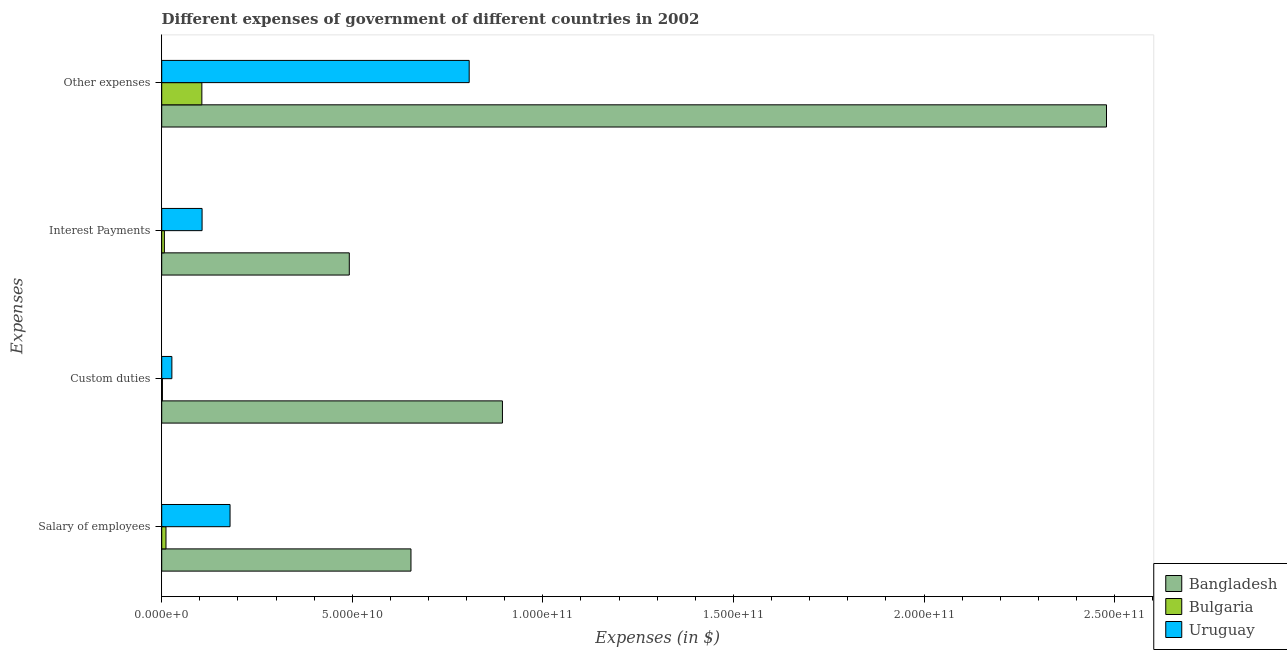How many different coloured bars are there?
Ensure brevity in your answer.  3. How many groups of bars are there?
Make the answer very short. 4. What is the label of the 1st group of bars from the top?
Ensure brevity in your answer.  Other expenses. What is the amount spent on other expenses in Bulgaria?
Your response must be concise. 1.05e+1. Across all countries, what is the maximum amount spent on interest payments?
Your answer should be compact. 4.92e+1. Across all countries, what is the minimum amount spent on interest payments?
Make the answer very short. 7.01e+08. In which country was the amount spent on interest payments minimum?
Your response must be concise. Bulgaria. What is the total amount spent on other expenses in the graph?
Make the answer very short. 3.39e+11. What is the difference between the amount spent on other expenses in Bulgaria and that in Uruguay?
Provide a short and direct response. -7.01e+1. What is the difference between the amount spent on salary of employees in Bangladesh and the amount spent on interest payments in Uruguay?
Provide a short and direct response. 5.48e+1. What is the average amount spent on salary of employees per country?
Make the answer very short. 2.81e+1. What is the difference between the amount spent on salary of employees and amount spent on interest payments in Bulgaria?
Your answer should be compact. 4.22e+08. What is the ratio of the amount spent on interest payments in Bangladesh to that in Bulgaria?
Make the answer very short. 70.2. What is the difference between the highest and the second highest amount spent on salary of employees?
Provide a short and direct response. 4.75e+1. What is the difference between the highest and the lowest amount spent on custom duties?
Your response must be concise. 8.92e+1. In how many countries, is the amount spent on interest payments greater than the average amount spent on interest payments taken over all countries?
Your answer should be compact. 1. Is the sum of the amount spent on custom duties in Bangladesh and Bulgaria greater than the maximum amount spent on interest payments across all countries?
Your answer should be compact. Yes. What does the 1st bar from the top in Interest Payments represents?
Ensure brevity in your answer.  Uruguay. What does the 2nd bar from the bottom in Custom duties represents?
Offer a terse response. Bulgaria. Is it the case that in every country, the sum of the amount spent on salary of employees and amount spent on custom duties is greater than the amount spent on interest payments?
Make the answer very short. Yes. Are all the bars in the graph horizontal?
Make the answer very short. Yes. What is the difference between two consecutive major ticks on the X-axis?
Ensure brevity in your answer.  5.00e+1. Does the graph contain any zero values?
Your answer should be very brief. No. Does the graph contain grids?
Provide a succinct answer. No. What is the title of the graph?
Your answer should be compact. Different expenses of government of different countries in 2002. What is the label or title of the X-axis?
Your answer should be very brief. Expenses (in $). What is the label or title of the Y-axis?
Offer a terse response. Expenses. What is the Expenses (in $) of Bangladesh in Salary of employees?
Your answer should be compact. 6.54e+1. What is the Expenses (in $) in Bulgaria in Salary of employees?
Ensure brevity in your answer.  1.12e+09. What is the Expenses (in $) of Uruguay in Salary of employees?
Give a very brief answer. 1.79e+1. What is the Expenses (in $) in Bangladesh in Custom duties?
Ensure brevity in your answer.  8.94e+1. What is the Expenses (in $) of Bulgaria in Custom duties?
Offer a very short reply. 1.88e+08. What is the Expenses (in $) in Uruguay in Custom duties?
Ensure brevity in your answer.  2.67e+09. What is the Expenses (in $) in Bangladesh in Interest Payments?
Provide a short and direct response. 4.92e+1. What is the Expenses (in $) in Bulgaria in Interest Payments?
Give a very brief answer. 7.01e+08. What is the Expenses (in $) in Uruguay in Interest Payments?
Give a very brief answer. 1.06e+1. What is the Expenses (in $) in Bangladesh in Other expenses?
Offer a very short reply. 2.48e+11. What is the Expenses (in $) of Bulgaria in Other expenses?
Offer a very short reply. 1.05e+1. What is the Expenses (in $) in Uruguay in Other expenses?
Offer a terse response. 8.07e+1. Across all Expenses, what is the maximum Expenses (in $) in Bangladesh?
Provide a succinct answer. 2.48e+11. Across all Expenses, what is the maximum Expenses (in $) of Bulgaria?
Offer a very short reply. 1.05e+1. Across all Expenses, what is the maximum Expenses (in $) in Uruguay?
Ensure brevity in your answer.  8.07e+1. Across all Expenses, what is the minimum Expenses (in $) in Bangladesh?
Make the answer very short. 4.92e+1. Across all Expenses, what is the minimum Expenses (in $) of Bulgaria?
Provide a succinct answer. 1.88e+08. Across all Expenses, what is the minimum Expenses (in $) in Uruguay?
Offer a very short reply. 2.67e+09. What is the total Expenses (in $) of Bangladesh in the graph?
Keep it short and to the point. 4.52e+11. What is the total Expenses (in $) of Bulgaria in the graph?
Your response must be concise. 1.25e+1. What is the total Expenses (in $) in Uruguay in the graph?
Ensure brevity in your answer.  1.12e+11. What is the difference between the Expenses (in $) of Bangladesh in Salary of employees and that in Custom duties?
Make the answer very short. -2.40e+1. What is the difference between the Expenses (in $) in Bulgaria in Salary of employees and that in Custom duties?
Make the answer very short. 9.34e+08. What is the difference between the Expenses (in $) of Uruguay in Salary of employees and that in Custom duties?
Offer a terse response. 1.53e+1. What is the difference between the Expenses (in $) of Bangladesh in Salary of employees and that in Interest Payments?
Offer a very short reply. 1.62e+1. What is the difference between the Expenses (in $) in Bulgaria in Salary of employees and that in Interest Payments?
Make the answer very short. 4.22e+08. What is the difference between the Expenses (in $) in Uruguay in Salary of employees and that in Interest Payments?
Make the answer very short. 7.34e+09. What is the difference between the Expenses (in $) in Bangladesh in Salary of employees and that in Other expenses?
Provide a succinct answer. -1.82e+11. What is the difference between the Expenses (in $) of Bulgaria in Salary of employees and that in Other expenses?
Your answer should be very brief. -9.41e+09. What is the difference between the Expenses (in $) of Uruguay in Salary of employees and that in Other expenses?
Ensure brevity in your answer.  -6.27e+1. What is the difference between the Expenses (in $) of Bangladesh in Custom duties and that in Interest Payments?
Keep it short and to the point. 4.02e+1. What is the difference between the Expenses (in $) in Bulgaria in Custom duties and that in Interest Payments?
Your answer should be compact. -5.13e+08. What is the difference between the Expenses (in $) in Uruguay in Custom duties and that in Interest Payments?
Offer a terse response. -7.92e+09. What is the difference between the Expenses (in $) in Bangladesh in Custom duties and that in Other expenses?
Provide a succinct answer. -1.58e+11. What is the difference between the Expenses (in $) in Bulgaria in Custom duties and that in Other expenses?
Make the answer very short. -1.03e+1. What is the difference between the Expenses (in $) in Uruguay in Custom duties and that in Other expenses?
Your response must be concise. -7.80e+1. What is the difference between the Expenses (in $) of Bangladesh in Interest Payments and that in Other expenses?
Your answer should be compact. -1.99e+11. What is the difference between the Expenses (in $) in Bulgaria in Interest Payments and that in Other expenses?
Offer a terse response. -9.83e+09. What is the difference between the Expenses (in $) in Uruguay in Interest Payments and that in Other expenses?
Your answer should be compact. -7.01e+1. What is the difference between the Expenses (in $) in Bangladesh in Salary of employees and the Expenses (in $) in Bulgaria in Custom duties?
Keep it short and to the point. 6.52e+1. What is the difference between the Expenses (in $) of Bangladesh in Salary of employees and the Expenses (in $) of Uruguay in Custom duties?
Your response must be concise. 6.27e+1. What is the difference between the Expenses (in $) in Bulgaria in Salary of employees and the Expenses (in $) in Uruguay in Custom duties?
Offer a terse response. -1.54e+09. What is the difference between the Expenses (in $) of Bangladesh in Salary of employees and the Expenses (in $) of Bulgaria in Interest Payments?
Provide a succinct answer. 6.47e+1. What is the difference between the Expenses (in $) in Bangladesh in Salary of employees and the Expenses (in $) in Uruguay in Interest Payments?
Your answer should be compact. 5.48e+1. What is the difference between the Expenses (in $) in Bulgaria in Salary of employees and the Expenses (in $) in Uruguay in Interest Payments?
Provide a short and direct response. -9.47e+09. What is the difference between the Expenses (in $) of Bangladesh in Salary of employees and the Expenses (in $) of Bulgaria in Other expenses?
Your response must be concise. 5.49e+1. What is the difference between the Expenses (in $) of Bangladesh in Salary of employees and the Expenses (in $) of Uruguay in Other expenses?
Give a very brief answer. -1.53e+1. What is the difference between the Expenses (in $) of Bulgaria in Salary of employees and the Expenses (in $) of Uruguay in Other expenses?
Your response must be concise. -7.95e+1. What is the difference between the Expenses (in $) of Bangladesh in Custom duties and the Expenses (in $) of Bulgaria in Interest Payments?
Your response must be concise. 8.87e+1. What is the difference between the Expenses (in $) in Bangladesh in Custom duties and the Expenses (in $) in Uruguay in Interest Payments?
Offer a terse response. 7.88e+1. What is the difference between the Expenses (in $) of Bulgaria in Custom duties and the Expenses (in $) of Uruguay in Interest Payments?
Your answer should be compact. -1.04e+1. What is the difference between the Expenses (in $) of Bangladesh in Custom duties and the Expenses (in $) of Bulgaria in Other expenses?
Your answer should be compact. 7.89e+1. What is the difference between the Expenses (in $) of Bangladesh in Custom duties and the Expenses (in $) of Uruguay in Other expenses?
Your answer should be compact. 8.72e+09. What is the difference between the Expenses (in $) in Bulgaria in Custom duties and the Expenses (in $) in Uruguay in Other expenses?
Provide a succinct answer. -8.05e+1. What is the difference between the Expenses (in $) in Bangladesh in Interest Payments and the Expenses (in $) in Bulgaria in Other expenses?
Make the answer very short. 3.87e+1. What is the difference between the Expenses (in $) of Bangladesh in Interest Payments and the Expenses (in $) of Uruguay in Other expenses?
Make the answer very short. -3.15e+1. What is the difference between the Expenses (in $) of Bulgaria in Interest Payments and the Expenses (in $) of Uruguay in Other expenses?
Provide a succinct answer. -8.00e+1. What is the average Expenses (in $) of Bangladesh per Expenses?
Your response must be concise. 1.13e+11. What is the average Expenses (in $) of Bulgaria per Expenses?
Give a very brief answer. 3.14e+09. What is the average Expenses (in $) of Uruguay per Expenses?
Keep it short and to the point. 2.80e+1. What is the difference between the Expenses (in $) in Bangladesh and Expenses (in $) in Bulgaria in Salary of employees?
Ensure brevity in your answer.  6.43e+1. What is the difference between the Expenses (in $) of Bangladesh and Expenses (in $) of Uruguay in Salary of employees?
Your response must be concise. 4.75e+1. What is the difference between the Expenses (in $) in Bulgaria and Expenses (in $) in Uruguay in Salary of employees?
Keep it short and to the point. -1.68e+1. What is the difference between the Expenses (in $) of Bangladesh and Expenses (in $) of Bulgaria in Custom duties?
Keep it short and to the point. 8.92e+1. What is the difference between the Expenses (in $) in Bangladesh and Expenses (in $) in Uruguay in Custom duties?
Offer a terse response. 8.67e+1. What is the difference between the Expenses (in $) of Bulgaria and Expenses (in $) of Uruguay in Custom duties?
Provide a succinct answer. -2.48e+09. What is the difference between the Expenses (in $) of Bangladesh and Expenses (in $) of Bulgaria in Interest Payments?
Your answer should be very brief. 4.85e+1. What is the difference between the Expenses (in $) in Bangladesh and Expenses (in $) in Uruguay in Interest Payments?
Ensure brevity in your answer.  3.86e+1. What is the difference between the Expenses (in $) of Bulgaria and Expenses (in $) of Uruguay in Interest Payments?
Your answer should be very brief. -9.89e+09. What is the difference between the Expenses (in $) in Bangladesh and Expenses (in $) in Bulgaria in Other expenses?
Give a very brief answer. 2.37e+11. What is the difference between the Expenses (in $) of Bangladesh and Expenses (in $) of Uruguay in Other expenses?
Your response must be concise. 1.67e+11. What is the difference between the Expenses (in $) in Bulgaria and Expenses (in $) in Uruguay in Other expenses?
Offer a terse response. -7.01e+1. What is the ratio of the Expenses (in $) of Bangladesh in Salary of employees to that in Custom duties?
Provide a succinct answer. 0.73. What is the ratio of the Expenses (in $) in Bulgaria in Salary of employees to that in Custom duties?
Provide a short and direct response. 5.96. What is the ratio of the Expenses (in $) in Uruguay in Salary of employees to that in Custom duties?
Offer a terse response. 6.72. What is the ratio of the Expenses (in $) in Bangladesh in Salary of employees to that in Interest Payments?
Your response must be concise. 1.33. What is the ratio of the Expenses (in $) of Bulgaria in Salary of employees to that in Interest Payments?
Your answer should be compact. 1.6. What is the ratio of the Expenses (in $) in Uruguay in Salary of employees to that in Interest Payments?
Offer a terse response. 1.69. What is the ratio of the Expenses (in $) in Bangladesh in Salary of employees to that in Other expenses?
Make the answer very short. 0.26. What is the ratio of the Expenses (in $) in Bulgaria in Salary of employees to that in Other expenses?
Provide a succinct answer. 0.11. What is the ratio of the Expenses (in $) in Uruguay in Salary of employees to that in Other expenses?
Keep it short and to the point. 0.22. What is the ratio of the Expenses (in $) in Bangladesh in Custom duties to that in Interest Payments?
Give a very brief answer. 1.82. What is the ratio of the Expenses (in $) in Bulgaria in Custom duties to that in Interest Payments?
Offer a very short reply. 0.27. What is the ratio of the Expenses (in $) of Uruguay in Custom duties to that in Interest Payments?
Keep it short and to the point. 0.25. What is the ratio of the Expenses (in $) in Bangladesh in Custom duties to that in Other expenses?
Provide a succinct answer. 0.36. What is the ratio of the Expenses (in $) in Bulgaria in Custom duties to that in Other expenses?
Your response must be concise. 0.02. What is the ratio of the Expenses (in $) of Uruguay in Custom duties to that in Other expenses?
Provide a short and direct response. 0.03. What is the ratio of the Expenses (in $) in Bangladesh in Interest Payments to that in Other expenses?
Your answer should be compact. 0.2. What is the ratio of the Expenses (in $) in Bulgaria in Interest Payments to that in Other expenses?
Give a very brief answer. 0.07. What is the ratio of the Expenses (in $) in Uruguay in Interest Payments to that in Other expenses?
Give a very brief answer. 0.13. What is the difference between the highest and the second highest Expenses (in $) in Bangladesh?
Offer a very short reply. 1.58e+11. What is the difference between the highest and the second highest Expenses (in $) in Bulgaria?
Your answer should be compact. 9.41e+09. What is the difference between the highest and the second highest Expenses (in $) in Uruguay?
Keep it short and to the point. 6.27e+1. What is the difference between the highest and the lowest Expenses (in $) of Bangladesh?
Your response must be concise. 1.99e+11. What is the difference between the highest and the lowest Expenses (in $) in Bulgaria?
Your answer should be compact. 1.03e+1. What is the difference between the highest and the lowest Expenses (in $) in Uruguay?
Give a very brief answer. 7.80e+1. 